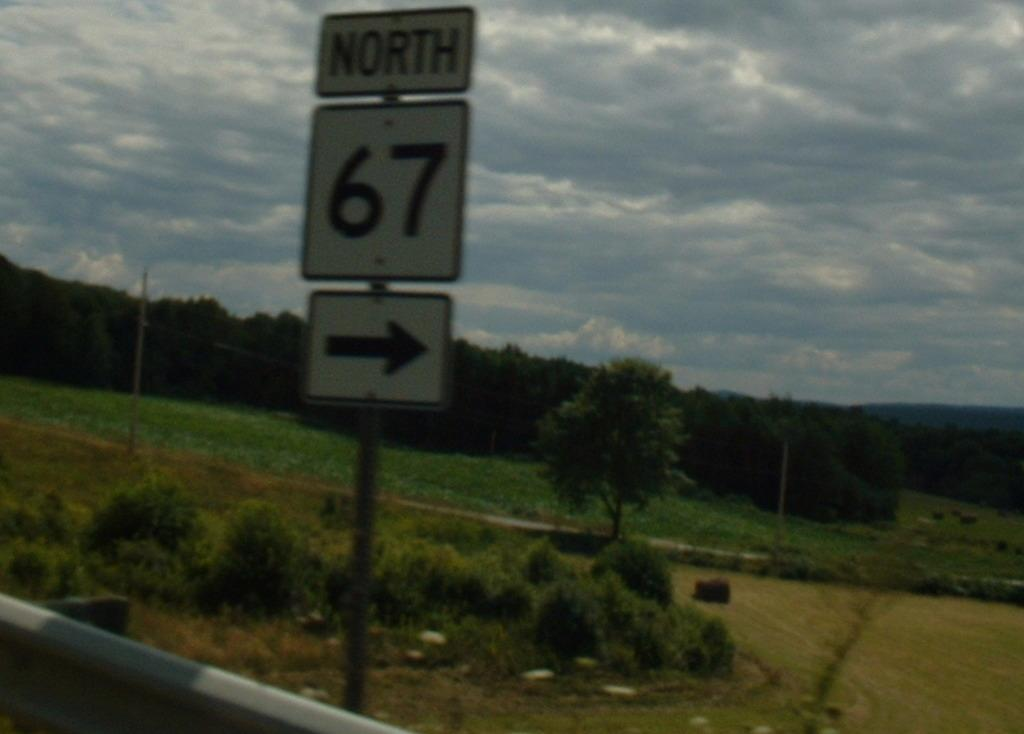<image>
Describe the image concisely. A road sign has an arrow that directs drivers north to highway 67, on the side of a country road. 